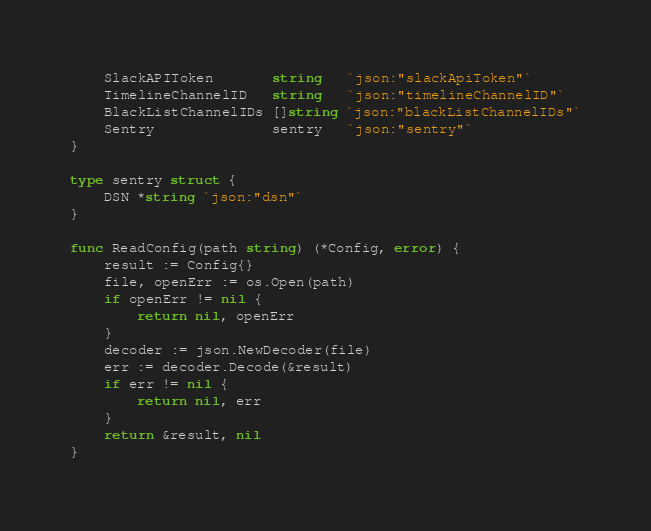Convert code to text. <code><loc_0><loc_0><loc_500><loc_500><_Go_>	SlackAPIToken       string   `json:"slackApiToken"`
	TimelineChannelID   string   `json:"timelineChannelID"`
	BlackListChannelIDs []string `json:"blackListChannelIDs"`
	Sentry              sentry   `json:"sentry"`
}

type sentry struct {
	DSN *string `json:"dsn"`
}

func ReadConfig(path string) (*Config, error) {
	result := Config{}
	file, openErr := os.Open(path)
	if openErr != nil {
		return nil, openErr
	}
	decoder := json.NewDecoder(file)
	err := decoder.Decode(&result)
	if err != nil {
		return nil, err
	}
	return &result, nil
}
</code> 